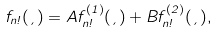Convert formula to latex. <formula><loc_0><loc_0><loc_500><loc_500>f _ { n \omega } ( \xi ) = A f _ { n \omega } ^ { ( 1 ) } ( \xi ) + B f _ { n \omega } ^ { ( 2 ) } ( \xi ) ,</formula> 